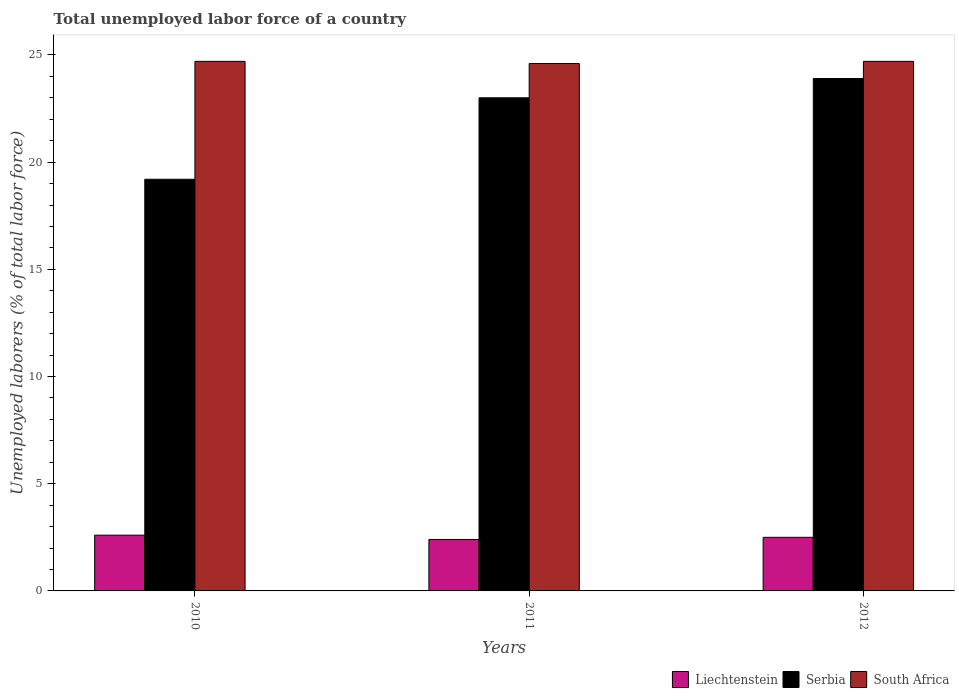How many different coloured bars are there?
Offer a terse response. 3. How many groups of bars are there?
Offer a very short reply. 3. How many bars are there on the 2nd tick from the left?
Your response must be concise. 3. How many bars are there on the 1st tick from the right?
Give a very brief answer. 3. What is the total unemployed labor force in South Africa in 2012?
Make the answer very short. 24.7. Across all years, what is the maximum total unemployed labor force in South Africa?
Provide a short and direct response. 24.7. Across all years, what is the minimum total unemployed labor force in South Africa?
Offer a terse response. 24.6. What is the total total unemployed labor force in South Africa in the graph?
Keep it short and to the point. 74. What is the difference between the total unemployed labor force in Liechtenstein in 2010 and that in 2012?
Offer a terse response. 0.1. What is the difference between the total unemployed labor force in Liechtenstein in 2010 and the total unemployed labor force in South Africa in 2012?
Your response must be concise. -22.1. In the year 2010, what is the difference between the total unemployed labor force in Serbia and total unemployed labor force in Liechtenstein?
Offer a very short reply. 16.6. In how many years, is the total unemployed labor force in Liechtenstein greater than 16 %?
Offer a very short reply. 0. What is the ratio of the total unemployed labor force in South Africa in 2010 to that in 2011?
Offer a terse response. 1. Is the total unemployed labor force in South Africa in 2010 less than that in 2011?
Give a very brief answer. No. What is the difference between the highest and the second highest total unemployed labor force in Liechtenstein?
Give a very brief answer. 0.1. What is the difference between the highest and the lowest total unemployed labor force in Liechtenstein?
Your response must be concise. 0.2. In how many years, is the total unemployed labor force in South Africa greater than the average total unemployed labor force in South Africa taken over all years?
Offer a very short reply. 2. What does the 3rd bar from the left in 2010 represents?
Make the answer very short. South Africa. What does the 3rd bar from the right in 2011 represents?
Your answer should be compact. Liechtenstein. How many bars are there?
Make the answer very short. 9. How many years are there in the graph?
Offer a very short reply. 3. What is the difference between two consecutive major ticks on the Y-axis?
Offer a very short reply. 5. Are the values on the major ticks of Y-axis written in scientific E-notation?
Your answer should be compact. No. Does the graph contain any zero values?
Keep it short and to the point. No. Where does the legend appear in the graph?
Give a very brief answer. Bottom right. How many legend labels are there?
Your answer should be very brief. 3. How are the legend labels stacked?
Offer a terse response. Horizontal. What is the title of the graph?
Provide a short and direct response. Total unemployed labor force of a country. What is the label or title of the Y-axis?
Provide a short and direct response. Unemployed laborers (% of total labor force). What is the Unemployed laborers (% of total labor force) in Liechtenstein in 2010?
Your answer should be very brief. 2.6. What is the Unemployed laborers (% of total labor force) in Serbia in 2010?
Make the answer very short. 19.2. What is the Unemployed laborers (% of total labor force) of South Africa in 2010?
Your answer should be very brief. 24.7. What is the Unemployed laborers (% of total labor force) in Liechtenstein in 2011?
Make the answer very short. 2.4. What is the Unemployed laborers (% of total labor force) in South Africa in 2011?
Your response must be concise. 24.6. What is the Unemployed laborers (% of total labor force) in Serbia in 2012?
Your response must be concise. 23.9. What is the Unemployed laborers (% of total labor force) in South Africa in 2012?
Offer a very short reply. 24.7. Across all years, what is the maximum Unemployed laborers (% of total labor force) in Liechtenstein?
Your answer should be very brief. 2.6. Across all years, what is the maximum Unemployed laborers (% of total labor force) of Serbia?
Ensure brevity in your answer.  23.9. Across all years, what is the maximum Unemployed laborers (% of total labor force) of South Africa?
Provide a short and direct response. 24.7. Across all years, what is the minimum Unemployed laborers (% of total labor force) of Liechtenstein?
Give a very brief answer. 2.4. Across all years, what is the minimum Unemployed laborers (% of total labor force) of Serbia?
Make the answer very short. 19.2. Across all years, what is the minimum Unemployed laborers (% of total labor force) of South Africa?
Provide a short and direct response. 24.6. What is the total Unemployed laborers (% of total labor force) in Liechtenstein in the graph?
Make the answer very short. 7.5. What is the total Unemployed laborers (% of total labor force) of Serbia in the graph?
Your answer should be very brief. 66.1. What is the total Unemployed laborers (% of total labor force) of South Africa in the graph?
Provide a short and direct response. 74. What is the difference between the Unemployed laborers (% of total labor force) in Liechtenstein in 2010 and that in 2011?
Your answer should be very brief. 0.2. What is the difference between the Unemployed laborers (% of total labor force) of South Africa in 2010 and that in 2011?
Give a very brief answer. 0.1. What is the difference between the Unemployed laborers (% of total labor force) in Serbia in 2010 and that in 2012?
Make the answer very short. -4.7. What is the difference between the Unemployed laborers (% of total labor force) of Liechtenstein in 2011 and that in 2012?
Provide a short and direct response. -0.1. What is the difference between the Unemployed laborers (% of total labor force) of Liechtenstein in 2010 and the Unemployed laborers (% of total labor force) of Serbia in 2011?
Offer a terse response. -20.4. What is the difference between the Unemployed laborers (% of total labor force) of Liechtenstein in 2010 and the Unemployed laborers (% of total labor force) of South Africa in 2011?
Your answer should be compact. -22. What is the difference between the Unemployed laborers (% of total labor force) in Liechtenstein in 2010 and the Unemployed laborers (% of total labor force) in Serbia in 2012?
Make the answer very short. -21.3. What is the difference between the Unemployed laborers (% of total labor force) of Liechtenstein in 2010 and the Unemployed laborers (% of total labor force) of South Africa in 2012?
Your answer should be compact. -22.1. What is the difference between the Unemployed laborers (% of total labor force) in Serbia in 2010 and the Unemployed laborers (% of total labor force) in South Africa in 2012?
Your answer should be compact. -5.5. What is the difference between the Unemployed laborers (% of total labor force) in Liechtenstein in 2011 and the Unemployed laborers (% of total labor force) in Serbia in 2012?
Provide a succinct answer. -21.5. What is the difference between the Unemployed laborers (% of total labor force) in Liechtenstein in 2011 and the Unemployed laborers (% of total labor force) in South Africa in 2012?
Keep it short and to the point. -22.3. What is the average Unemployed laborers (% of total labor force) of Serbia per year?
Provide a short and direct response. 22.03. What is the average Unemployed laborers (% of total labor force) in South Africa per year?
Ensure brevity in your answer.  24.67. In the year 2010, what is the difference between the Unemployed laborers (% of total labor force) of Liechtenstein and Unemployed laborers (% of total labor force) of Serbia?
Offer a terse response. -16.6. In the year 2010, what is the difference between the Unemployed laborers (% of total labor force) in Liechtenstein and Unemployed laborers (% of total labor force) in South Africa?
Your answer should be compact. -22.1. In the year 2011, what is the difference between the Unemployed laborers (% of total labor force) of Liechtenstein and Unemployed laborers (% of total labor force) of Serbia?
Give a very brief answer. -20.6. In the year 2011, what is the difference between the Unemployed laborers (% of total labor force) of Liechtenstein and Unemployed laborers (% of total labor force) of South Africa?
Offer a terse response. -22.2. In the year 2011, what is the difference between the Unemployed laborers (% of total labor force) of Serbia and Unemployed laborers (% of total labor force) of South Africa?
Make the answer very short. -1.6. In the year 2012, what is the difference between the Unemployed laborers (% of total labor force) in Liechtenstein and Unemployed laborers (% of total labor force) in Serbia?
Ensure brevity in your answer.  -21.4. In the year 2012, what is the difference between the Unemployed laborers (% of total labor force) in Liechtenstein and Unemployed laborers (% of total labor force) in South Africa?
Your response must be concise. -22.2. What is the ratio of the Unemployed laborers (% of total labor force) in Serbia in 2010 to that in 2011?
Offer a very short reply. 0.83. What is the ratio of the Unemployed laborers (% of total labor force) of Liechtenstein in 2010 to that in 2012?
Make the answer very short. 1.04. What is the ratio of the Unemployed laborers (% of total labor force) of Serbia in 2010 to that in 2012?
Give a very brief answer. 0.8. What is the ratio of the Unemployed laborers (% of total labor force) in South Africa in 2010 to that in 2012?
Keep it short and to the point. 1. What is the ratio of the Unemployed laborers (% of total labor force) in Liechtenstein in 2011 to that in 2012?
Offer a terse response. 0.96. What is the ratio of the Unemployed laborers (% of total labor force) in Serbia in 2011 to that in 2012?
Keep it short and to the point. 0.96. What is the difference between the highest and the second highest Unemployed laborers (% of total labor force) of Liechtenstein?
Your answer should be compact. 0.1. What is the difference between the highest and the second highest Unemployed laborers (% of total labor force) of Serbia?
Provide a succinct answer. 0.9. What is the difference between the highest and the second highest Unemployed laborers (% of total labor force) in South Africa?
Make the answer very short. 0. What is the difference between the highest and the lowest Unemployed laborers (% of total labor force) of Serbia?
Give a very brief answer. 4.7. What is the difference between the highest and the lowest Unemployed laborers (% of total labor force) in South Africa?
Offer a very short reply. 0.1. 